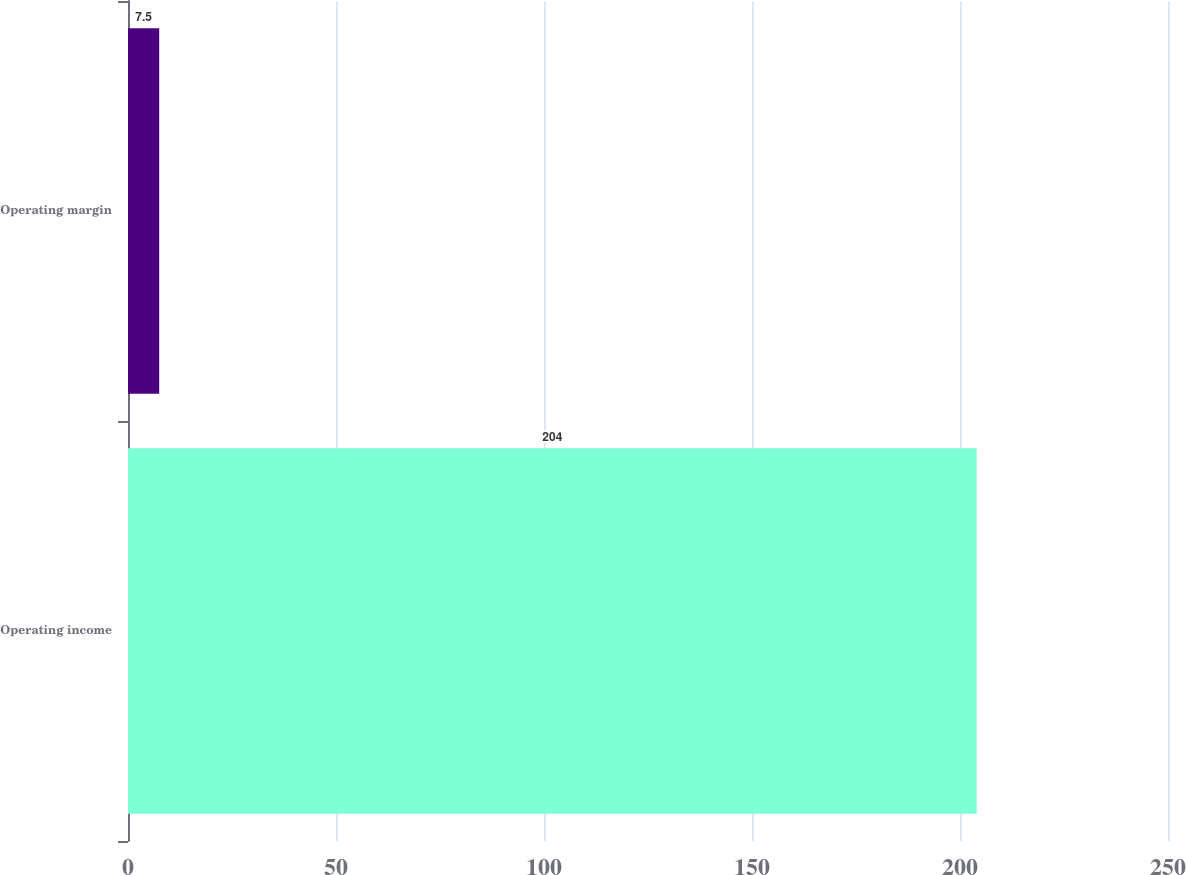Convert chart. <chart><loc_0><loc_0><loc_500><loc_500><bar_chart><fcel>Operating income<fcel>Operating margin<nl><fcel>204<fcel>7.5<nl></chart> 